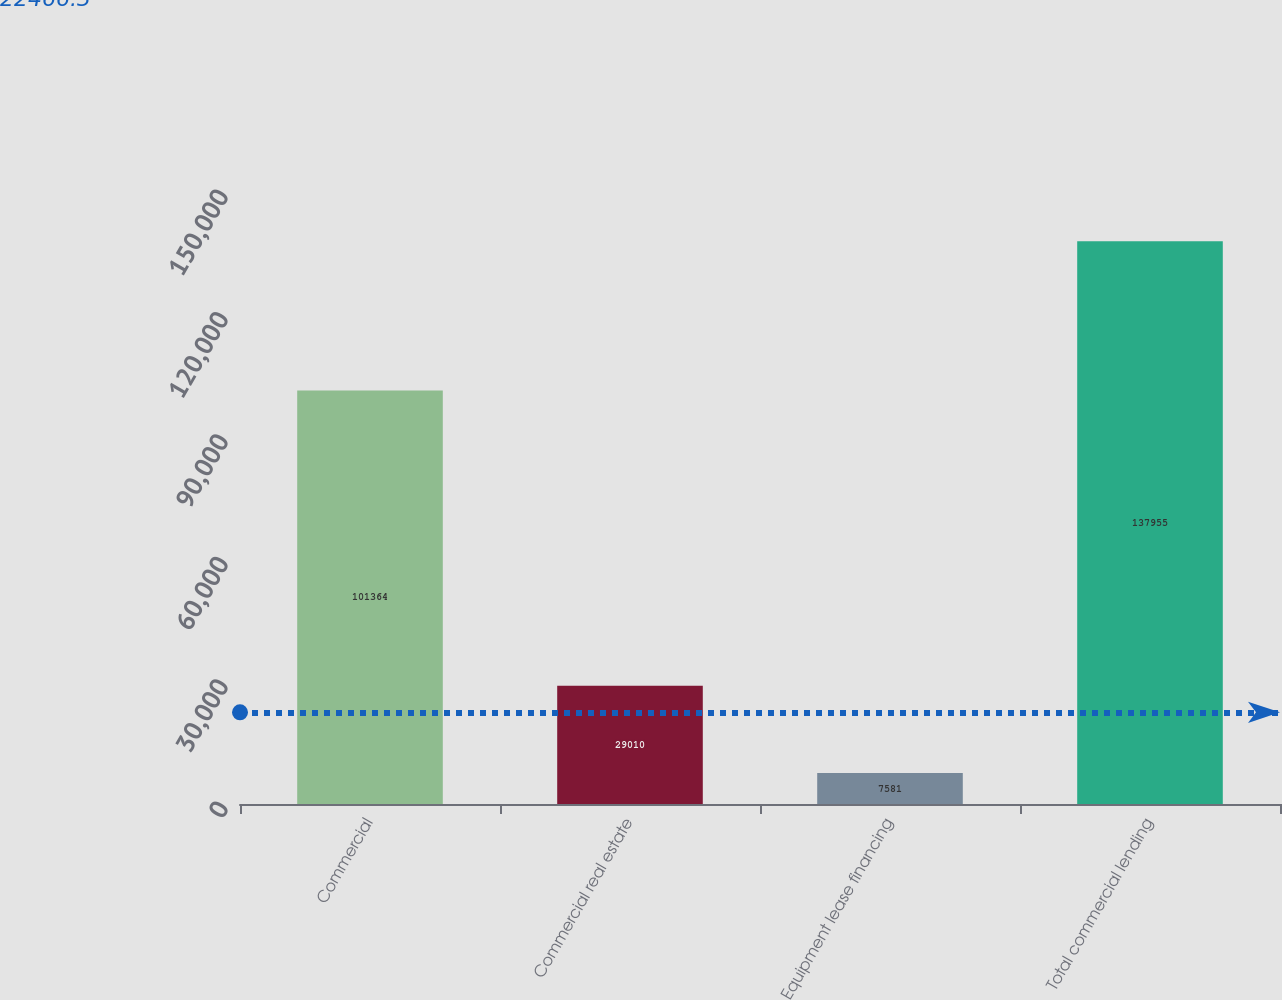Convert chart. <chart><loc_0><loc_0><loc_500><loc_500><bar_chart><fcel>Commercial<fcel>Commercial real estate<fcel>Equipment lease financing<fcel>Total commercial lending<nl><fcel>101364<fcel>29010<fcel>7581<fcel>137955<nl></chart> 